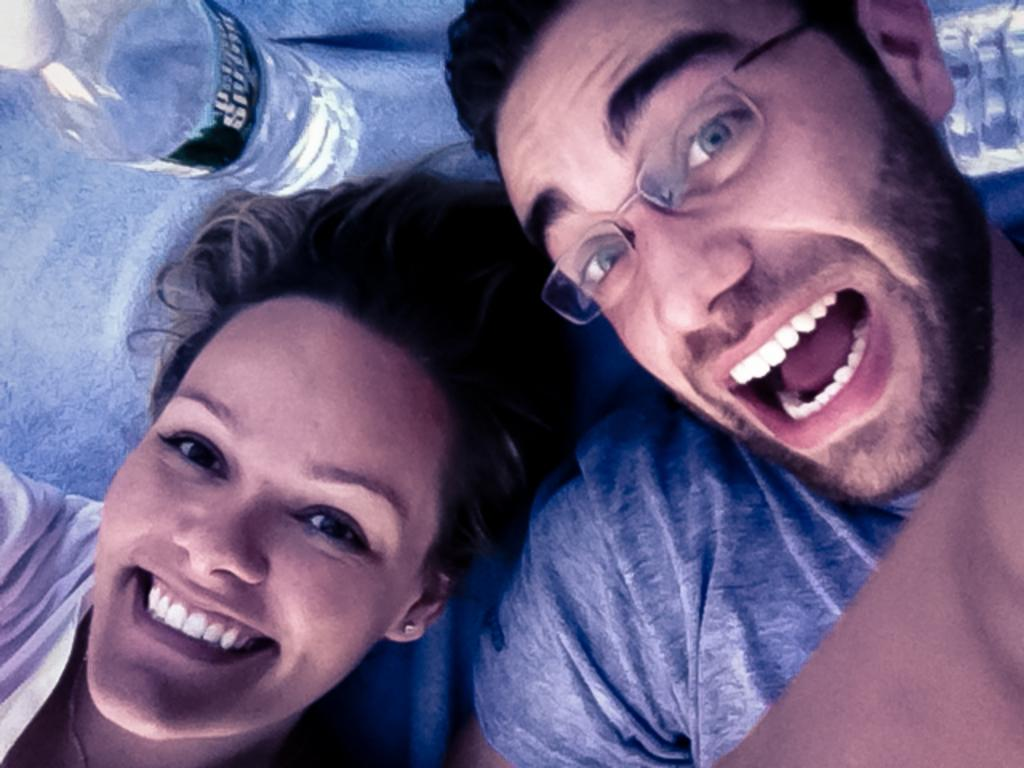Who are the people in the image? There is a girl and a boy in the image. What are the expressions on their faces? Both the girl and the boy are smiling in the image. What are they doing in the image? They are looking at the camera. What objects are near their heads? There are water bottles near their heads. What type of spot can be seen on the boy's shirt in the image? There is no spot visible on the boy's shirt in the image. What payment method is being used for the activity they are participating in? There is no indication of any payment method being used in the image. 